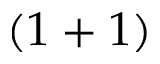<formula> <loc_0><loc_0><loc_500><loc_500>( 1 + 1 )</formula> 